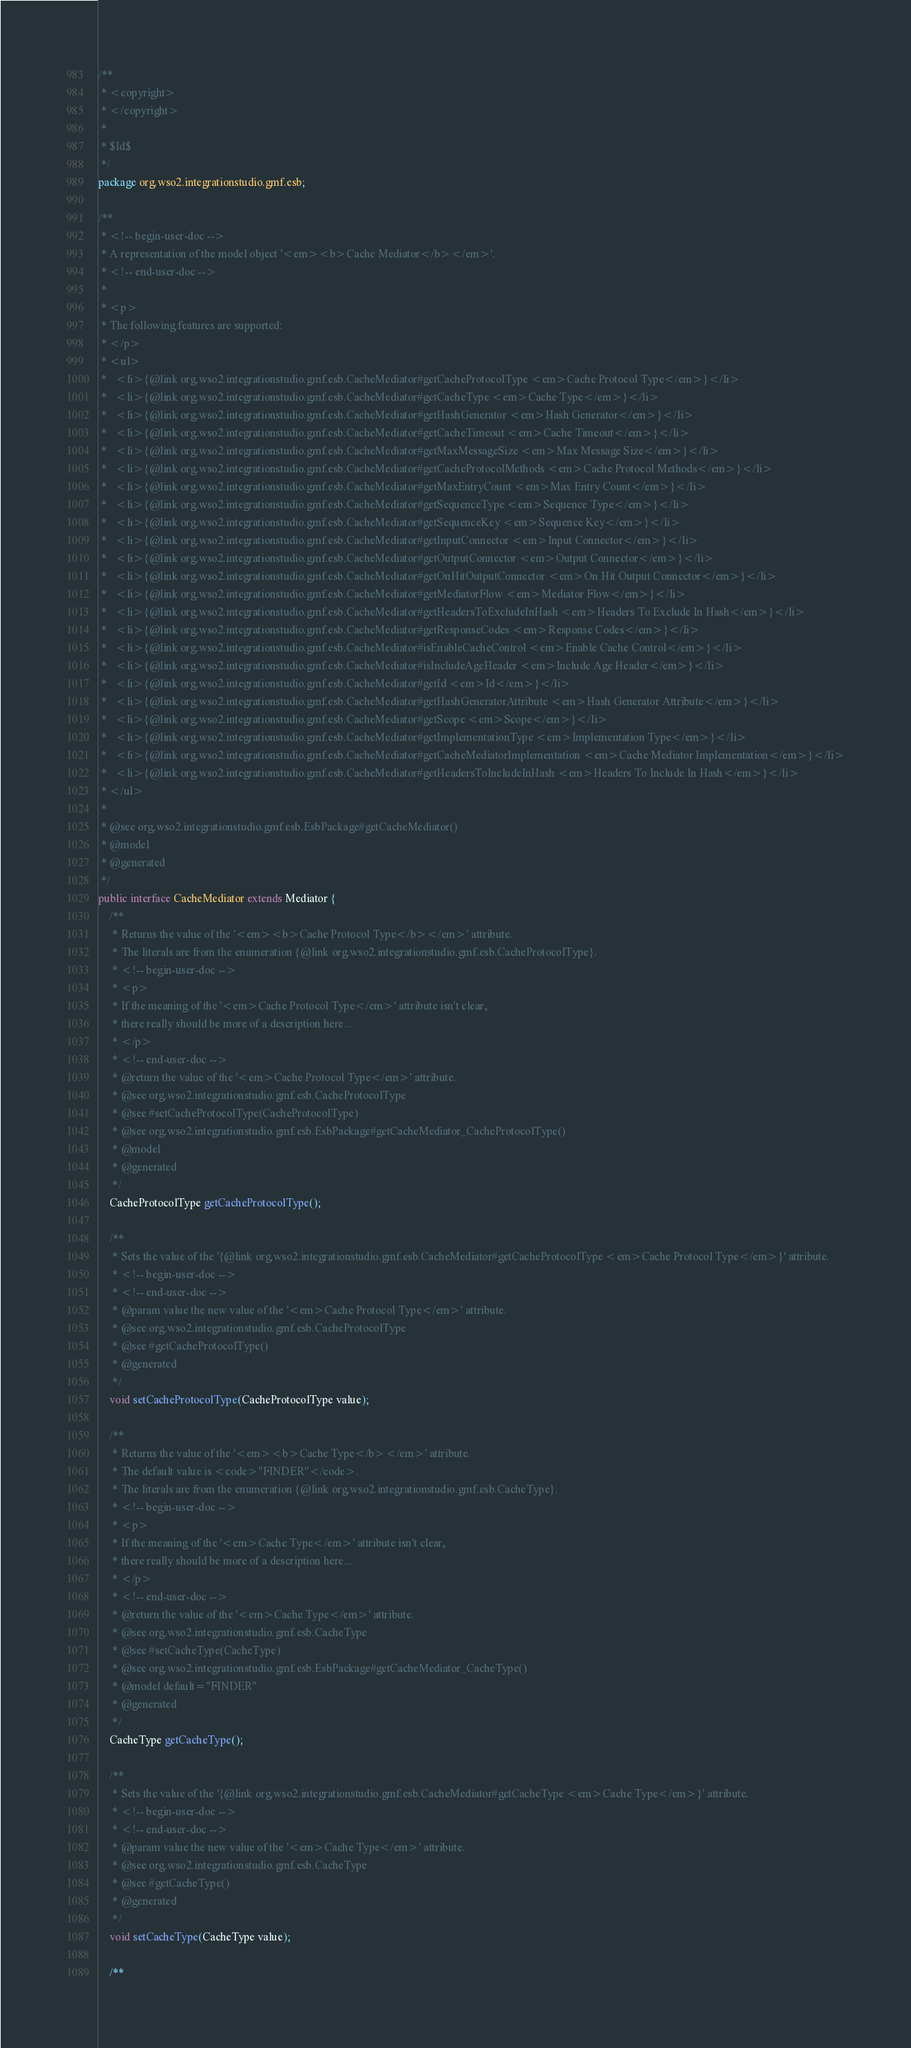Convert code to text. <code><loc_0><loc_0><loc_500><loc_500><_Java_>/**
 * <copyright>
 * </copyright>
 *
 * $Id$
 */
package org.wso2.integrationstudio.gmf.esb;

/**
 * <!-- begin-user-doc -->
 * A representation of the model object '<em><b>Cache Mediator</b></em>'.
 * <!-- end-user-doc -->
 *
 * <p>
 * The following features are supported:
 * </p>
 * <ul>
 *   <li>{@link org.wso2.integrationstudio.gmf.esb.CacheMediator#getCacheProtocolType <em>Cache Protocol Type</em>}</li>
 *   <li>{@link org.wso2.integrationstudio.gmf.esb.CacheMediator#getCacheType <em>Cache Type</em>}</li>
 *   <li>{@link org.wso2.integrationstudio.gmf.esb.CacheMediator#getHashGenerator <em>Hash Generator</em>}</li>
 *   <li>{@link org.wso2.integrationstudio.gmf.esb.CacheMediator#getCacheTimeout <em>Cache Timeout</em>}</li>
 *   <li>{@link org.wso2.integrationstudio.gmf.esb.CacheMediator#getMaxMessageSize <em>Max Message Size</em>}</li>
 *   <li>{@link org.wso2.integrationstudio.gmf.esb.CacheMediator#getCacheProtocolMethods <em>Cache Protocol Methods</em>}</li>
 *   <li>{@link org.wso2.integrationstudio.gmf.esb.CacheMediator#getMaxEntryCount <em>Max Entry Count</em>}</li>
 *   <li>{@link org.wso2.integrationstudio.gmf.esb.CacheMediator#getSequenceType <em>Sequence Type</em>}</li>
 *   <li>{@link org.wso2.integrationstudio.gmf.esb.CacheMediator#getSequenceKey <em>Sequence Key</em>}</li>
 *   <li>{@link org.wso2.integrationstudio.gmf.esb.CacheMediator#getInputConnector <em>Input Connector</em>}</li>
 *   <li>{@link org.wso2.integrationstudio.gmf.esb.CacheMediator#getOutputConnector <em>Output Connector</em>}</li>
 *   <li>{@link org.wso2.integrationstudio.gmf.esb.CacheMediator#getOnHitOutputConnector <em>On Hit Output Connector</em>}</li>
 *   <li>{@link org.wso2.integrationstudio.gmf.esb.CacheMediator#getMediatorFlow <em>Mediator Flow</em>}</li>
 *   <li>{@link org.wso2.integrationstudio.gmf.esb.CacheMediator#getHeadersToExcludeInHash <em>Headers To Exclude In Hash</em>}</li>
 *   <li>{@link org.wso2.integrationstudio.gmf.esb.CacheMediator#getResponseCodes <em>Response Codes</em>}</li>
 *   <li>{@link org.wso2.integrationstudio.gmf.esb.CacheMediator#isEnableCacheControl <em>Enable Cache Control</em>}</li>
 *   <li>{@link org.wso2.integrationstudio.gmf.esb.CacheMediator#isIncludeAgeHeader <em>Include Age Header</em>}</li>
 *   <li>{@link org.wso2.integrationstudio.gmf.esb.CacheMediator#getId <em>Id</em>}</li>
 *   <li>{@link org.wso2.integrationstudio.gmf.esb.CacheMediator#getHashGeneratorAttribute <em>Hash Generator Attribute</em>}</li>
 *   <li>{@link org.wso2.integrationstudio.gmf.esb.CacheMediator#getScope <em>Scope</em>}</li>
 *   <li>{@link org.wso2.integrationstudio.gmf.esb.CacheMediator#getImplementationType <em>Implementation Type</em>}</li>
 *   <li>{@link org.wso2.integrationstudio.gmf.esb.CacheMediator#getCacheMediatorImplementation <em>Cache Mediator Implementation</em>}</li>
 *   <li>{@link org.wso2.integrationstudio.gmf.esb.CacheMediator#getHeadersToIncludeInHash <em>Headers To Include In Hash</em>}</li>
 * </ul>
 *
 * @see org.wso2.integrationstudio.gmf.esb.EsbPackage#getCacheMediator()
 * @model
 * @generated
 */
public interface CacheMediator extends Mediator {
    /**
     * Returns the value of the '<em><b>Cache Protocol Type</b></em>' attribute.
     * The literals are from the enumeration {@link org.wso2.integrationstudio.gmf.esb.CacheProtocolType}.
     * <!-- begin-user-doc -->
     * <p>
     * If the meaning of the '<em>Cache Protocol Type</em>' attribute isn't clear,
     * there really should be more of a description here...
     * </p>
     * <!-- end-user-doc -->
     * @return the value of the '<em>Cache Protocol Type</em>' attribute.
     * @see org.wso2.integrationstudio.gmf.esb.CacheProtocolType
     * @see #setCacheProtocolType(CacheProtocolType)
     * @see org.wso2.integrationstudio.gmf.esb.EsbPackage#getCacheMediator_CacheProtocolType()
     * @model
     * @generated
     */
    CacheProtocolType getCacheProtocolType();

    /**
     * Sets the value of the '{@link org.wso2.integrationstudio.gmf.esb.CacheMediator#getCacheProtocolType <em>Cache Protocol Type</em>}' attribute.
     * <!-- begin-user-doc -->
     * <!-- end-user-doc -->
     * @param value the new value of the '<em>Cache Protocol Type</em>' attribute.
     * @see org.wso2.integrationstudio.gmf.esb.CacheProtocolType
     * @see #getCacheProtocolType()
     * @generated
     */
    void setCacheProtocolType(CacheProtocolType value);

    /**
     * Returns the value of the '<em><b>Cache Type</b></em>' attribute.
     * The default value is <code>"FINDER"</code>.
     * The literals are from the enumeration {@link org.wso2.integrationstudio.gmf.esb.CacheType}.
     * <!-- begin-user-doc -->
     * <p>
     * If the meaning of the '<em>Cache Type</em>' attribute isn't clear,
     * there really should be more of a description here...
     * </p>
     * <!-- end-user-doc -->
     * @return the value of the '<em>Cache Type</em>' attribute.
     * @see org.wso2.integrationstudio.gmf.esb.CacheType
     * @see #setCacheType(CacheType)
     * @see org.wso2.integrationstudio.gmf.esb.EsbPackage#getCacheMediator_CacheType()
     * @model default="FINDER"
     * @generated
     */
    CacheType getCacheType();

    /**
     * Sets the value of the '{@link org.wso2.integrationstudio.gmf.esb.CacheMediator#getCacheType <em>Cache Type</em>}' attribute.
     * <!-- begin-user-doc -->
     * <!-- end-user-doc -->
     * @param value the new value of the '<em>Cache Type</em>' attribute.
     * @see org.wso2.integrationstudio.gmf.esb.CacheType
     * @see #getCacheType()
     * @generated
     */
    void setCacheType(CacheType value);

    /**</code> 